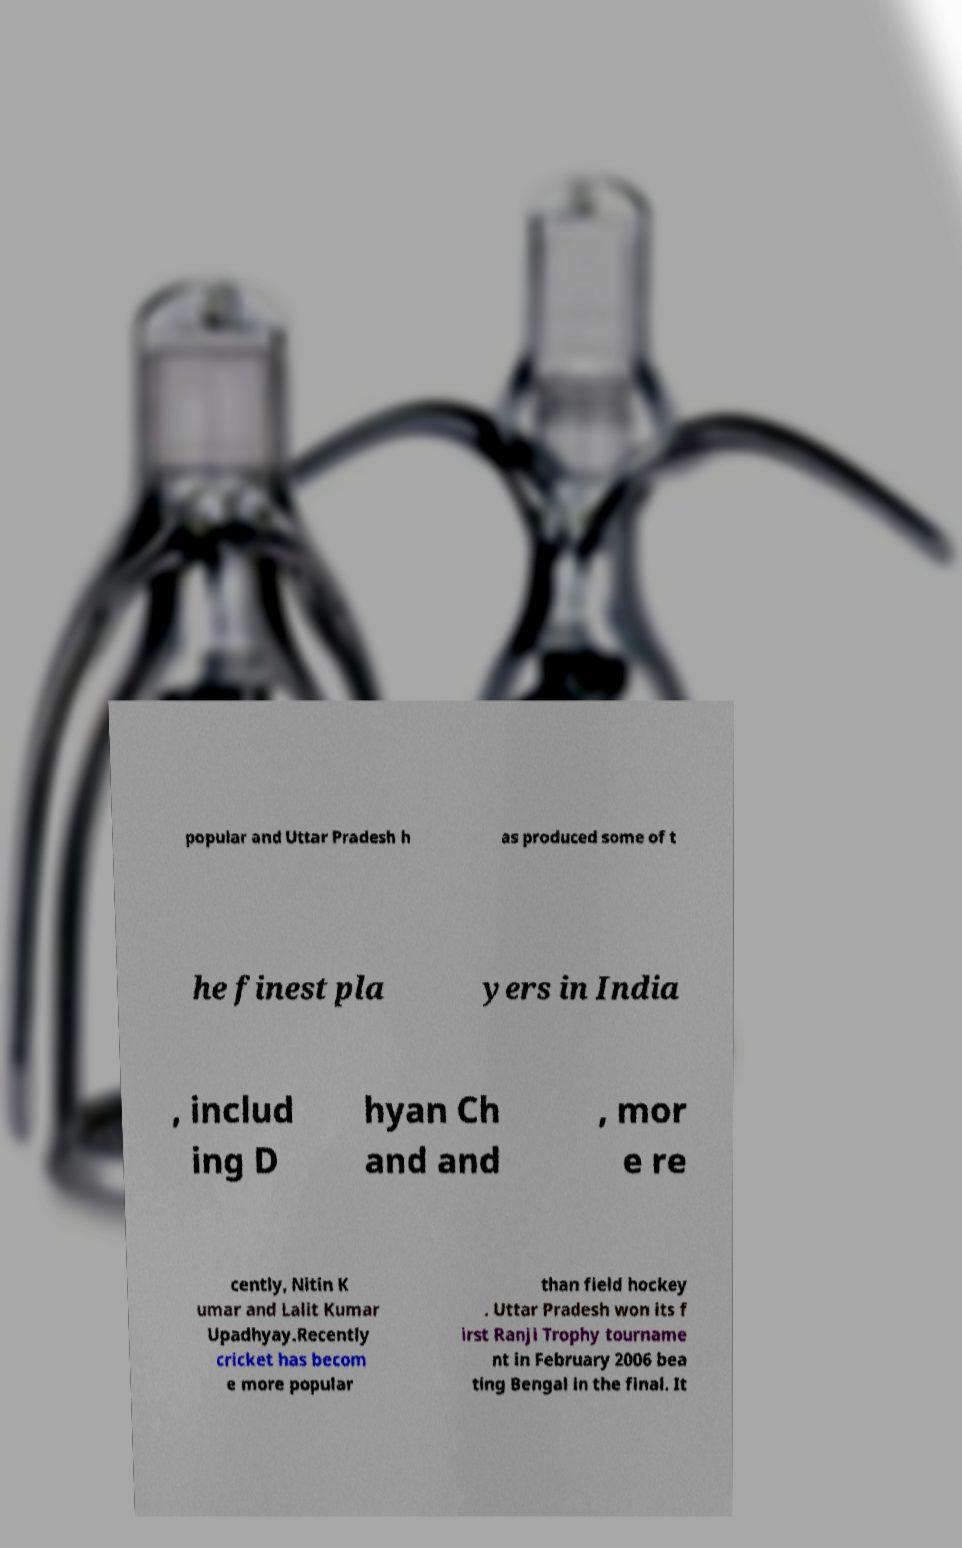What messages or text are displayed in this image? I need them in a readable, typed format. popular and Uttar Pradesh h as produced some of t he finest pla yers in India , includ ing D hyan Ch and and , mor e re cently, Nitin K umar and Lalit Kumar Upadhyay.Recently cricket has becom e more popular than field hockey . Uttar Pradesh won its f irst Ranji Trophy tourname nt in February 2006 bea ting Bengal in the final. It 